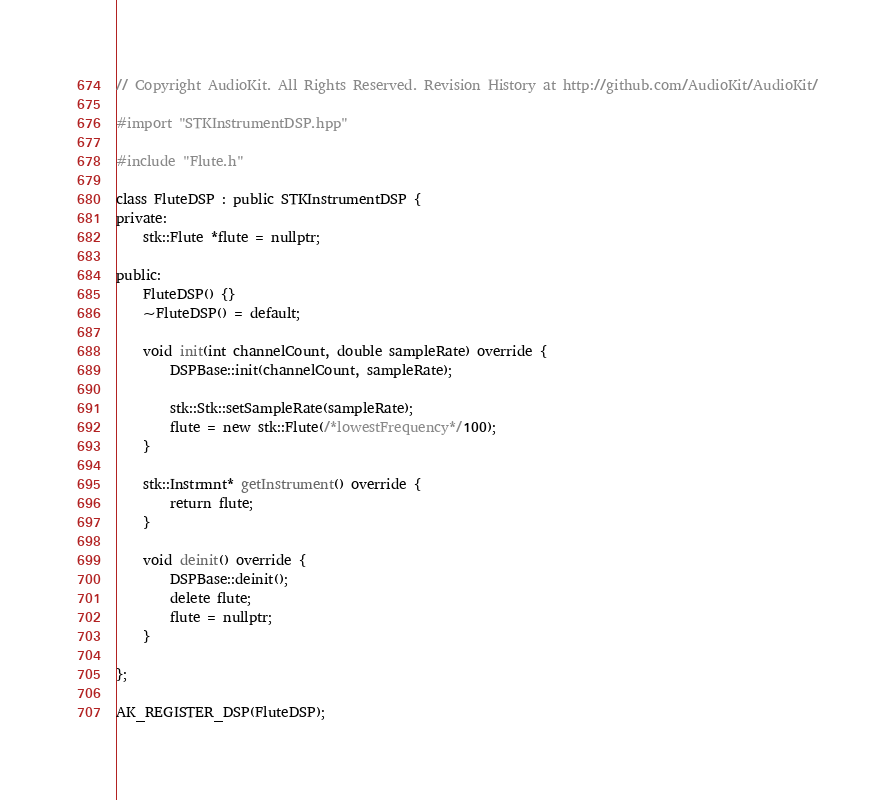<code> <loc_0><loc_0><loc_500><loc_500><_ObjectiveC_>// Copyright AudioKit. All Rights Reserved. Revision History at http://github.com/AudioKit/AudioKit/

#import "STKInstrumentDSP.hpp"

#include "Flute.h"

class FluteDSP : public STKInstrumentDSP {
private:
    stk::Flute *flute = nullptr;

public:
    FluteDSP() {}
    ~FluteDSP() = default;

    void init(int channelCount, double sampleRate) override {
        DSPBase::init(channelCount, sampleRate);

        stk::Stk::setSampleRate(sampleRate);
        flute = new stk::Flute(/*lowestFrequency*/100);
    }

    stk::Instrmnt* getInstrument() override {
        return flute;
    }

    void deinit() override {
        DSPBase::deinit();
        delete flute;
        flute = nullptr;
    }

};

AK_REGISTER_DSP(FluteDSP);
</code> 